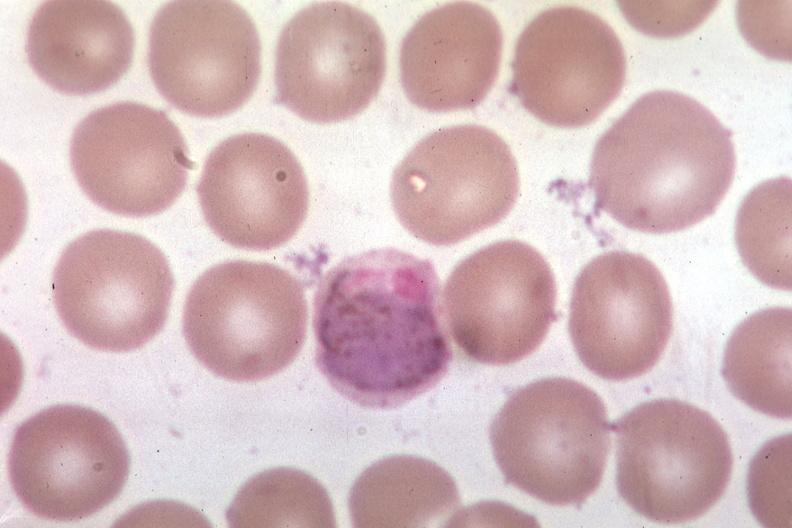s siamese twins present?
Answer the question using a single word or phrase. No 